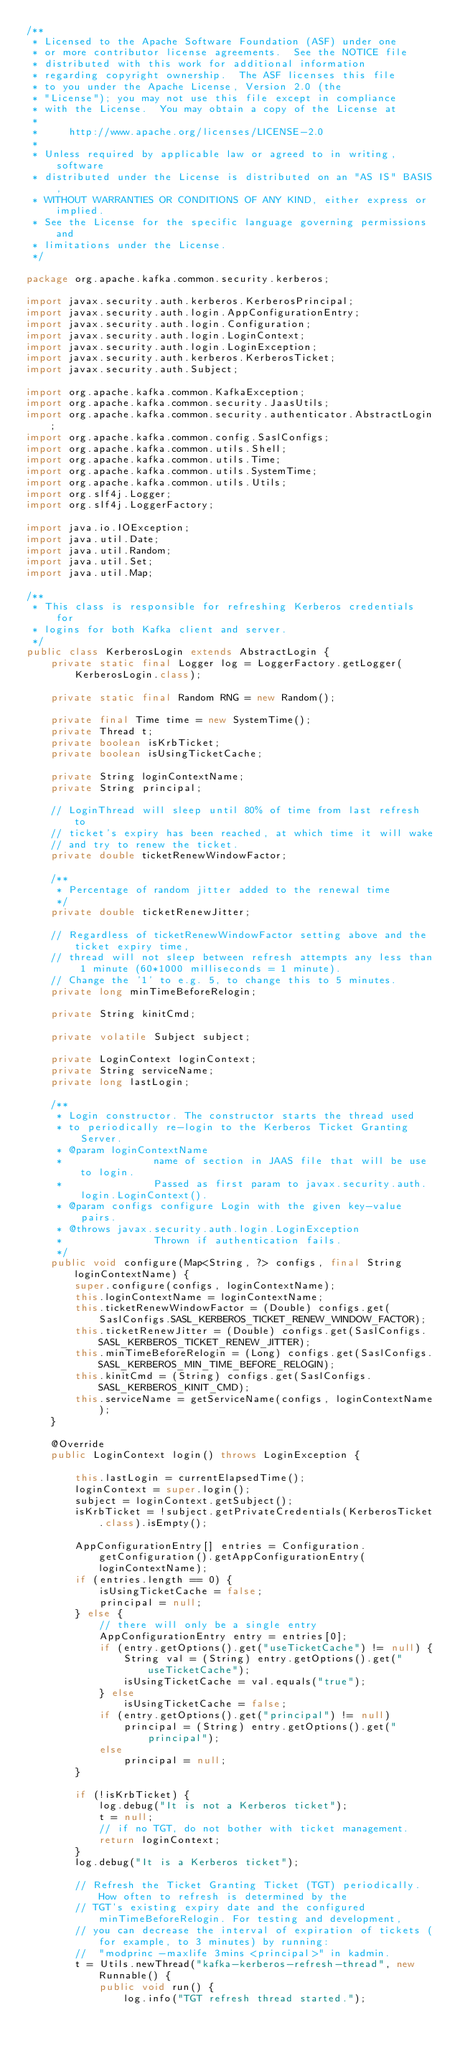Convert code to text. <code><loc_0><loc_0><loc_500><loc_500><_Java_>/**
 * Licensed to the Apache Software Foundation (ASF) under one
 * or more contributor license agreements.  See the NOTICE file
 * distributed with this work for additional information
 * regarding copyright ownership.  The ASF licenses this file
 * to you under the Apache License, Version 2.0 (the
 * "License"); you may not use this file except in compliance
 * with the License.  You may obtain a copy of the License at
 *
 *     http://www.apache.org/licenses/LICENSE-2.0
 *
 * Unless required by applicable law or agreed to in writing, software
 * distributed under the License is distributed on an "AS IS" BASIS,
 * WITHOUT WARRANTIES OR CONDITIONS OF ANY KIND, either express or implied.
 * See the License for the specific language governing permissions and
 * limitations under the License.
 */

package org.apache.kafka.common.security.kerberos;

import javax.security.auth.kerberos.KerberosPrincipal;
import javax.security.auth.login.AppConfigurationEntry;
import javax.security.auth.login.Configuration;
import javax.security.auth.login.LoginContext;
import javax.security.auth.login.LoginException;
import javax.security.auth.kerberos.KerberosTicket;
import javax.security.auth.Subject;

import org.apache.kafka.common.KafkaException;
import org.apache.kafka.common.security.JaasUtils;
import org.apache.kafka.common.security.authenticator.AbstractLogin;
import org.apache.kafka.common.config.SaslConfigs;
import org.apache.kafka.common.utils.Shell;
import org.apache.kafka.common.utils.Time;
import org.apache.kafka.common.utils.SystemTime;
import org.apache.kafka.common.utils.Utils;
import org.slf4j.Logger;
import org.slf4j.LoggerFactory;

import java.io.IOException;
import java.util.Date;
import java.util.Random;
import java.util.Set;
import java.util.Map;

/**
 * This class is responsible for refreshing Kerberos credentials for
 * logins for both Kafka client and server.
 */
public class KerberosLogin extends AbstractLogin {
    private static final Logger log = LoggerFactory.getLogger(KerberosLogin.class);

    private static final Random RNG = new Random();

    private final Time time = new SystemTime();
    private Thread t;
    private boolean isKrbTicket;
    private boolean isUsingTicketCache;

    private String loginContextName;
    private String principal;

    // LoginThread will sleep until 80% of time from last refresh to
    // ticket's expiry has been reached, at which time it will wake
    // and try to renew the ticket.
    private double ticketRenewWindowFactor;

    /**
     * Percentage of random jitter added to the renewal time
     */
    private double ticketRenewJitter;

    // Regardless of ticketRenewWindowFactor setting above and the ticket expiry time,
    // thread will not sleep between refresh attempts any less than 1 minute (60*1000 milliseconds = 1 minute).
    // Change the '1' to e.g. 5, to change this to 5 minutes.
    private long minTimeBeforeRelogin;

    private String kinitCmd;

    private volatile Subject subject;

    private LoginContext loginContext;
    private String serviceName;
    private long lastLogin;

    /**
     * Login constructor. The constructor starts the thread used
     * to periodically re-login to the Kerberos Ticket Granting Server.
     * @param loginContextName
     *               name of section in JAAS file that will be use to login.
     *               Passed as first param to javax.security.auth.login.LoginContext().
     * @param configs configure Login with the given key-value pairs.
     * @throws javax.security.auth.login.LoginException
     *               Thrown if authentication fails.
     */
    public void configure(Map<String, ?> configs, final String loginContextName) {
        super.configure(configs, loginContextName);
        this.loginContextName = loginContextName;
        this.ticketRenewWindowFactor = (Double) configs.get(SaslConfigs.SASL_KERBEROS_TICKET_RENEW_WINDOW_FACTOR);
        this.ticketRenewJitter = (Double) configs.get(SaslConfigs.SASL_KERBEROS_TICKET_RENEW_JITTER);
        this.minTimeBeforeRelogin = (Long) configs.get(SaslConfigs.SASL_KERBEROS_MIN_TIME_BEFORE_RELOGIN);
        this.kinitCmd = (String) configs.get(SaslConfigs.SASL_KERBEROS_KINIT_CMD);
        this.serviceName = getServiceName(configs, loginContextName);
    }

    @Override
    public LoginContext login() throws LoginException {

        this.lastLogin = currentElapsedTime();
        loginContext = super.login();
        subject = loginContext.getSubject();
        isKrbTicket = !subject.getPrivateCredentials(KerberosTicket.class).isEmpty();

        AppConfigurationEntry[] entries = Configuration.getConfiguration().getAppConfigurationEntry(loginContextName);
        if (entries.length == 0) {
            isUsingTicketCache = false;
            principal = null;
        } else {
            // there will only be a single entry
            AppConfigurationEntry entry = entries[0];
            if (entry.getOptions().get("useTicketCache") != null) {
                String val = (String) entry.getOptions().get("useTicketCache");
                isUsingTicketCache = val.equals("true");
            } else
                isUsingTicketCache = false;
            if (entry.getOptions().get("principal") != null)
                principal = (String) entry.getOptions().get("principal");
            else
                principal = null;
        }

        if (!isKrbTicket) {
            log.debug("It is not a Kerberos ticket");
            t = null;
            // if no TGT, do not bother with ticket management.
            return loginContext;
        }
        log.debug("It is a Kerberos ticket");

        // Refresh the Ticket Granting Ticket (TGT) periodically. How often to refresh is determined by the
        // TGT's existing expiry date and the configured minTimeBeforeRelogin. For testing and development,
        // you can decrease the interval of expiration of tickets (for example, to 3 minutes) by running:
        //  "modprinc -maxlife 3mins <principal>" in kadmin.
        t = Utils.newThread("kafka-kerberos-refresh-thread", new Runnable() {
            public void run() {
                log.info("TGT refresh thread started.");</code> 